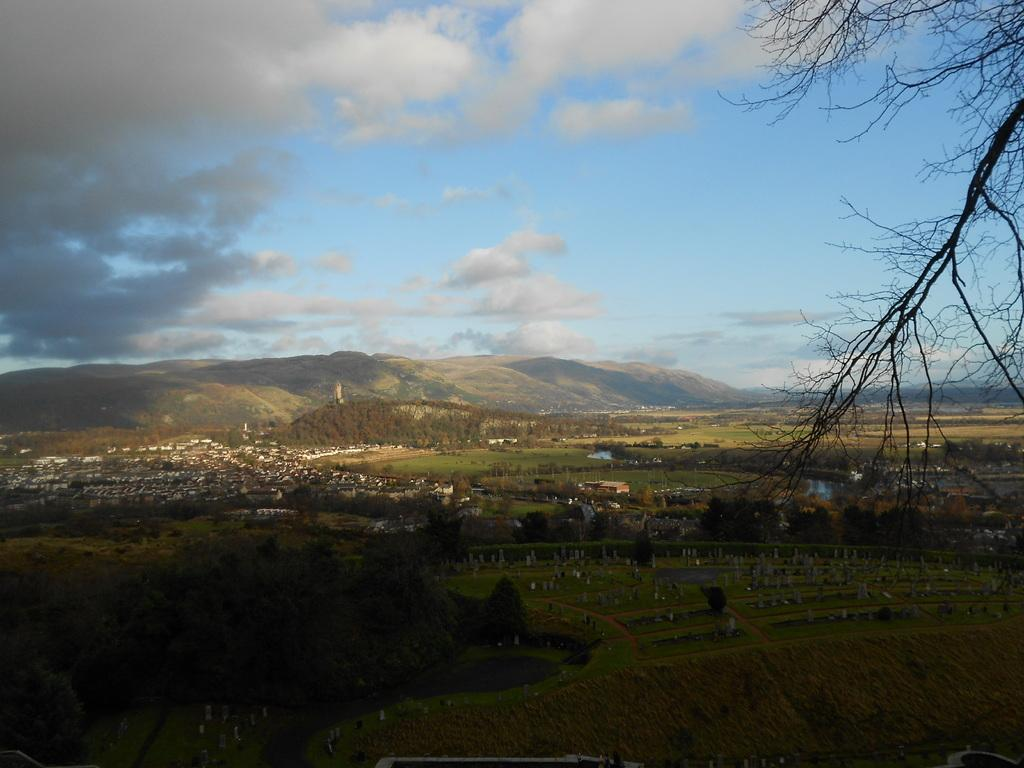What type of vegetation is present at the bottom of the image? There is grass and trees at the bottom of the image. What type of structures can be seen at the bottom of the image? There are buildings at the bottom of the image. What type of terrain is present at the bottom of the image? There are hills at the bottom of the image. What is visible at the top of the image? There are clouds and the sky visible at the top of the image. How do the giants interact with the clouds in the image? There are no giants present in the image; it features grass, trees, buildings, hills, clouds, and the sky. What is the surprise element in the image? There is no surprise element in the image; it is a straightforward depiction of grass, trees, buildings, hills, clouds, and the sky. 